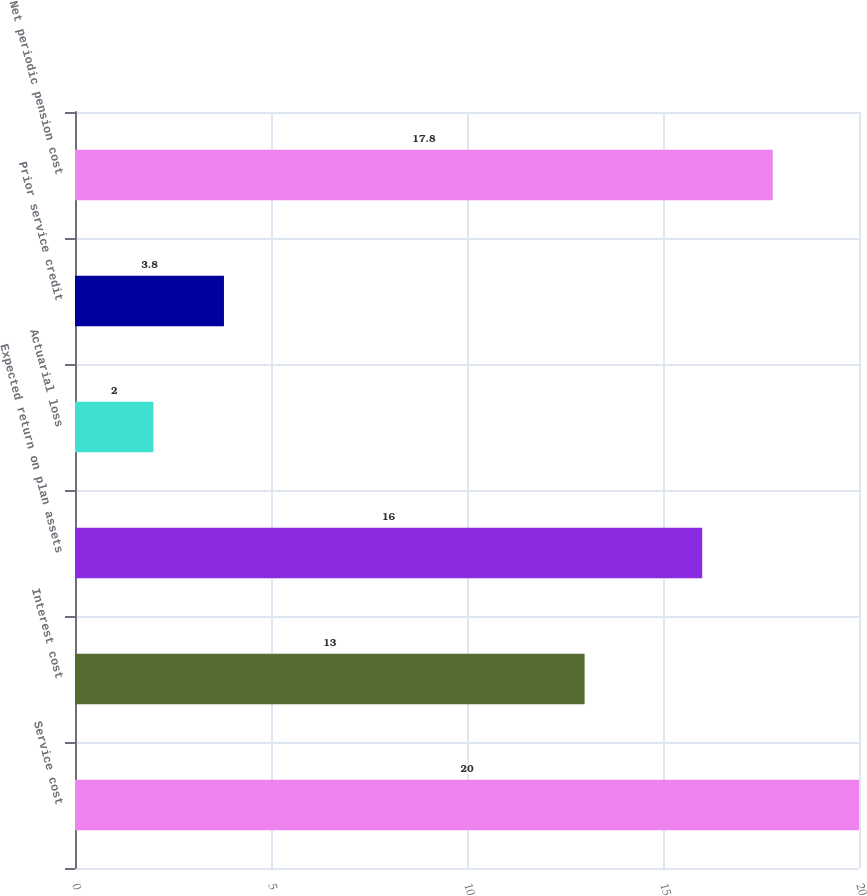<chart> <loc_0><loc_0><loc_500><loc_500><bar_chart><fcel>Service cost<fcel>Interest cost<fcel>Expected return on plan assets<fcel>Actuarial loss<fcel>Prior service credit<fcel>Net periodic pension cost<nl><fcel>20<fcel>13<fcel>16<fcel>2<fcel>3.8<fcel>17.8<nl></chart> 